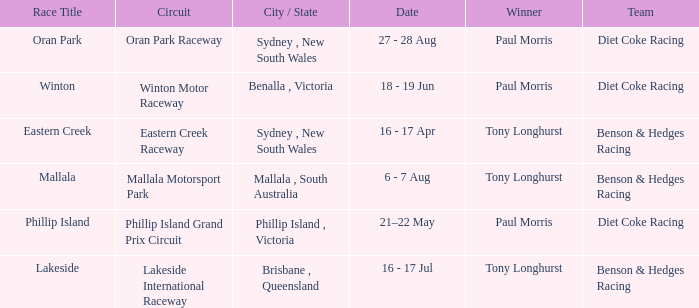Could you help me parse every detail presented in this table? {'header': ['Race Title', 'Circuit', 'City / State', 'Date', 'Winner', 'Team'], 'rows': [['Oran Park', 'Oran Park Raceway', 'Sydney , New South Wales', '27 - 28 Aug', 'Paul Morris', 'Diet Coke Racing'], ['Winton', 'Winton Motor Raceway', 'Benalla , Victoria', '18 - 19 Jun', 'Paul Morris', 'Diet Coke Racing'], ['Eastern Creek', 'Eastern Creek Raceway', 'Sydney , New South Wales', '16 - 17 Apr', 'Tony Longhurst', 'Benson & Hedges Racing'], ['Mallala', 'Mallala Motorsport Park', 'Mallala , South Australia', '6 - 7 Aug', 'Tony Longhurst', 'Benson & Hedges Racing'], ['Phillip Island', 'Phillip Island Grand Prix Circuit', 'Phillip Island , Victoria', '21–22 May', 'Paul Morris', 'Diet Coke Racing'], ['Lakeside', 'Lakeside International Raceway', 'Brisbane , Queensland', '16 - 17 Jul', 'Tony Longhurst', 'Benson & Hedges Racing']]} When was the Mallala race held? 6 - 7 Aug. 